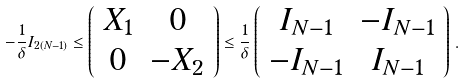Convert formula to latex. <formula><loc_0><loc_0><loc_500><loc_500>- \frac { 1 } { \delta } I _ { 2 ( N - 1 ) } \leq \left ( \begin{array} { c c } X _ { 1 } & 0 \\ 0 & - X _ { 2 } \end{array} \right ) \leq \frac { 1 } \delta \left ( \begin{array} { c c } I _ { N - 1 } & - I _ { N - 1 } \\ - I _ { N - 1 } & I _ { N - 1 } \end{array} \right ) \, .</formula> 